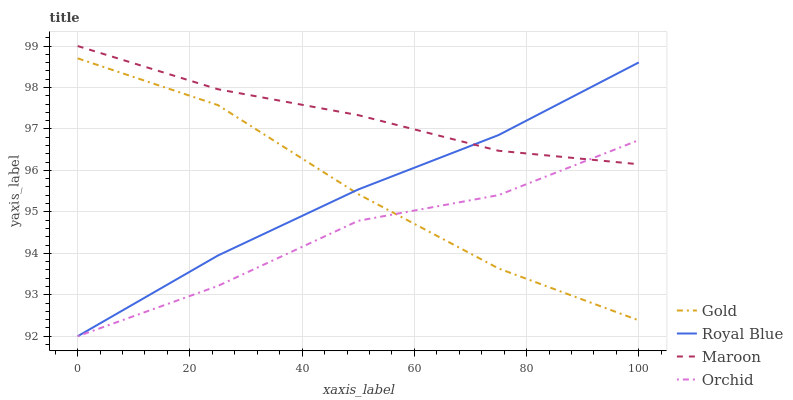Does Orchid have the minimum area under the curve?
Answer yes or no. Yes. Does Maroon have the maximum area under the curve?
Answer yes or no. Yes. Does Gold have the minimum area under the curve?
Answer yes or no. No. Does Gold have the maximum area under the curve?
Answer yes or no. No. Is Royal Blue the smoothest?
Answer yes or no. Yes. Is Orchid the roughest?
Answer yes or no. Yes. Is Maroon the smoothest?
Answer yes or no. No. Is Maroon the roughest?
Answer yes or no. No. Does Royal Blue have the lowest value?
Answer yes or no. Yes. Does Gold have the lowest value?
Answer yes or no. No. Does Maroon have the highest value?
Answer yes or no. Yes. Does Gold have the highest value?
Answer yes or no. No. Is Gold less than Maroon?
Answer yes or no. Yes. Is Maroon greater than Gold?
Answer yes or no. Yes. Does Orchid intersect Maroon?
Answer yes or no. Yes. Is Orchid less than Maroon?
Answer yes or no. No. Is Orchid greater than Maroon?
Answer yes or no. No. Does Gold intersect Maroon?
Answer yes or no. No. 